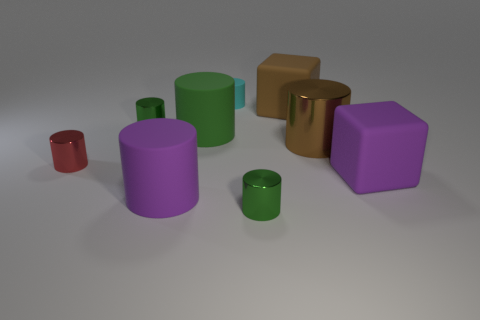How big is the red metal cylinder that is on the left side of the large brown matte object?
Provide a succinct answer. Small. There is a small thing that is both left of the big green rubber object and behind the large green matte thing; what shape is it?
Make the answer very short. Cylinder. How many other objects are there of the same shape as the tiny red thing?
Provide a short and direct response. 6. There is a metal cylinder that is the same size as the green rubber cylinder; what is its color?
Keep it short and to the point. Brown. What number of objects are large purple rubber things or tiny green objects?
Provide a short and direct response. 4. Are there any rubber cubes behind the red cylinder?
Your answer should be compact. Yes. Are there any brown cylinders that have the same material as the small red thing?
Provide a short and direct response. Yes. How many cylinders are either big metal things or tiny green objects?
Ensure brevity in your answer.  3. Are there more big cubes behind the big metal thing than big green rubber objects right of the cyan rubber cylinder?
Give a very brief answer. Yes. How many shiny objects have the same color as the small rubber cylinder?
Ensure brevity in your answer.  0. 